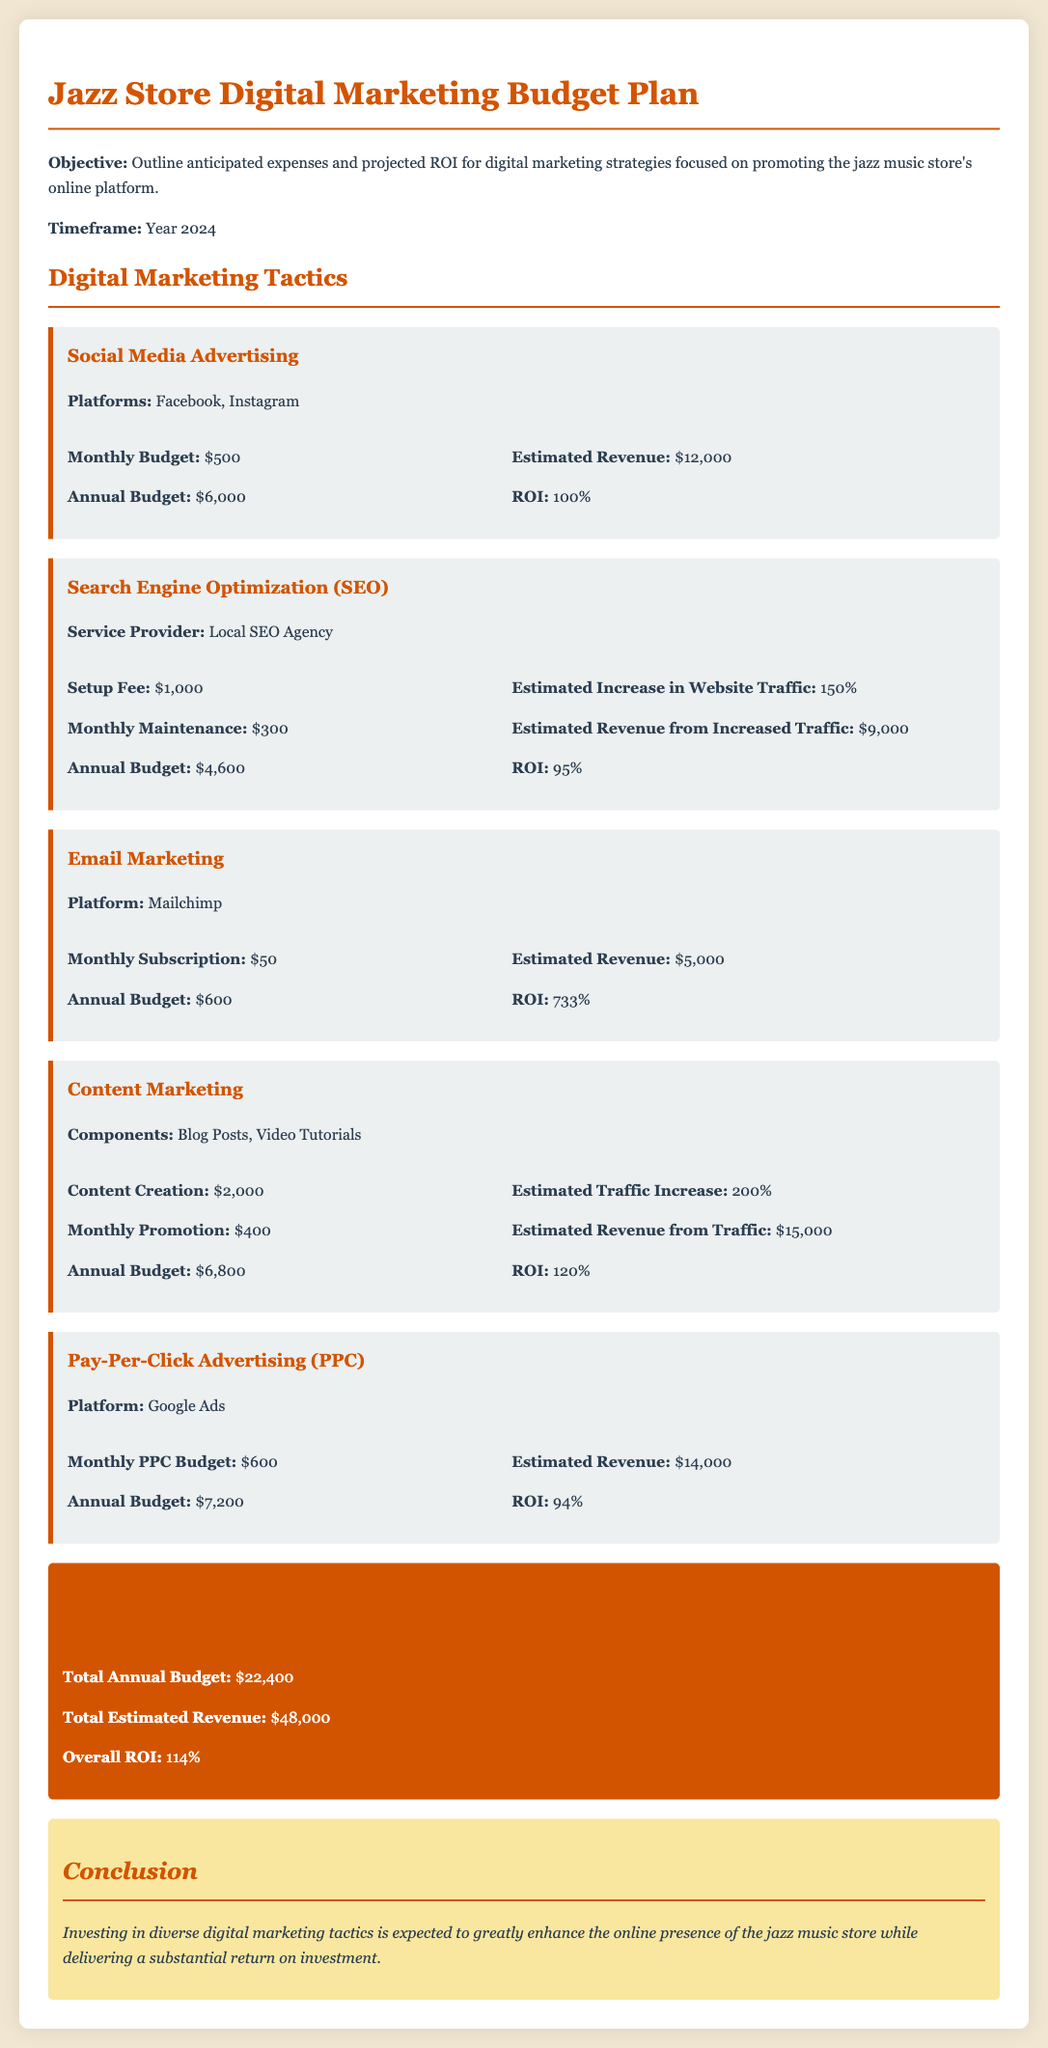What is the annual budget for Social Media Advertising? The annual budget for Social Media Advertising is specified in the document as $6,000.
Answer: $6,000 What is the estimated revenue from Email Marketing? The document states that the estimated revenue from Email Marketing is $5,000.
Answer: $5,000 What is the ROI for Content Marketing? The ROI for Content Marketing is detailed as 120% in the document.
Answer: 120% Who is the service provider for SEO? The document lists the service provider for SEO as a Local SEO Agency.
Answer: Local SEO Agency What is the total annual budget for all digital marketing tactics? The total annual budget is summarized in the document as $22,400.
Answer: $22,400 How much is the monthly PPC budget? According to the document, the monthly PPC budget is $600.
Answer: $600 What is the estimated revenue from Search Engine Optimization? The estimated revenue from SEO, as noted in the document, is $9,000.
Answer: $9,000 What is the timeframe for the budget plan outlined in the document? The document specifies that the timeframe for the budget plan is the Year 2024.
Answer: Year 2024 What is the overall ROI for the digital marketing initiatives? The document indicates that the overall ROI for the initiatives is 114%.
Answer: 114% 